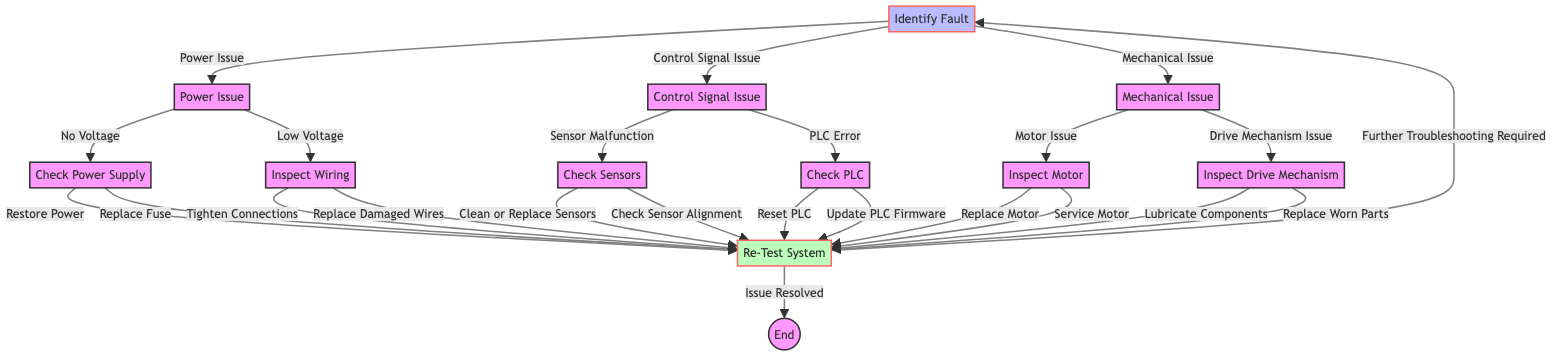What is the starting node of the decision tree? The starting node is "Identify Fault" which is where the troubleshooting process begins.
Answer: Identify Fault How many main categories of faults are identified in the first step? The first step lists three main categories: Power Issue, Control Signal Issue, and Mechanical Issue.
Answer: Three What action should be taken if there is no voltage? The appropriate action is to "Check Power Supply", which involves ensuring the main power supply is operational.
Answer: Check Power Supply What is the next step after identifying a "Control Signal Issue"? After identifying a Control Signal Issue, the next step is to check for either "Sensor Malfunction" or "PLC Error".
Answer: Check Sensors or Check PLC What should be done if the wiring is found to be damaged? If wiring is damaged, the troubleshooting step is to "Replace Damaged Wires".
Answer: Replace Damaged Wires What happens after a "Re-Test System"? After re-testing the system, if the issue is resolved, the process ends; if further troubleshooting is required, it leads back to "Identify Fault".
Answer: Issue Resolved or Further Troubleshooting Required Which node leads to actions involving motors? The node "Mechanical Issue" leads to actions involving motors, specifically inspecting the motor for faults.
Answer: Inspect Motor What is one possible solution for a sensor issue? One possible solution for a sensor issue is to "Clean or Replace Sensors".
Answer: Clean or Replace Sensors If the PLC firmware needs updating, what action should be taken? The action in this case is to "Update PLC Firmware" which is part of the steps for fixing a control signal issue.
Answer: Update PLC Firmware 